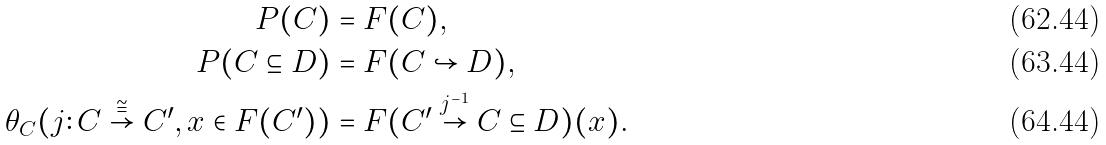Convert formula to latex. <formula><loc_0><loc_0><loc_500><loc_500>P ( C ) & = F ( C ) , \\ P ( C \subseteq D ) & = F ( C \hookrightarrow D ) , \\ \theta _ { C } ( j \colon C \stackrel { \cong } { \to } C ^ { \prime } , x \in F ( C ^ { \prime } ) ) & = F ( C ^ { \prime } \stackrel { j ^ { - 1 } } { \to } C \subseteq D ) ( x ) .</formula> 